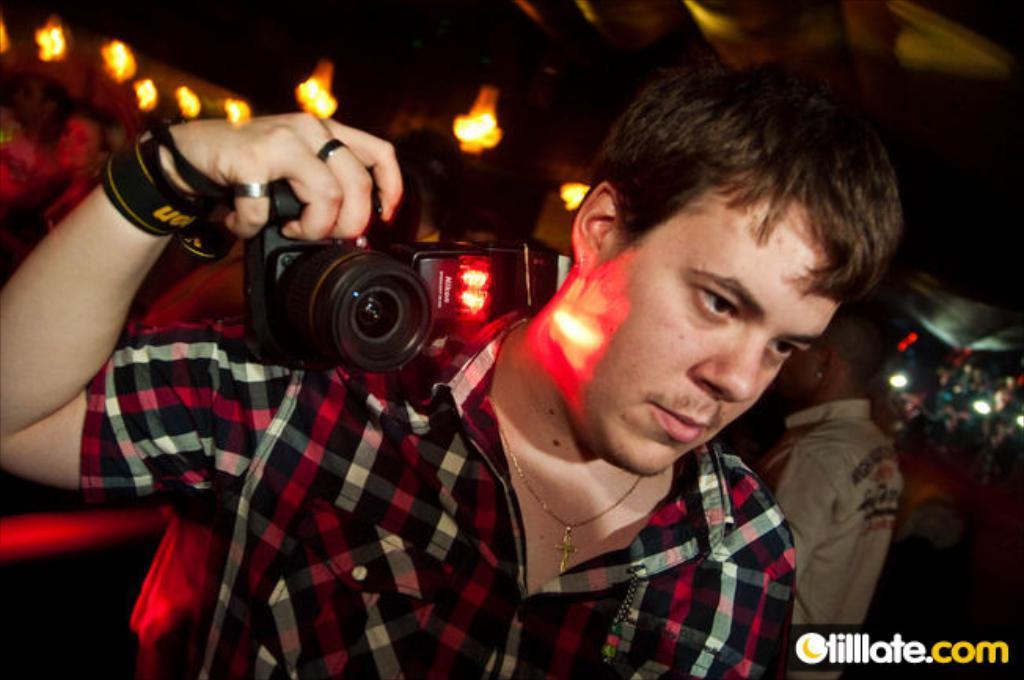How would you summarize this image in a sentence or two? In the image we can see there is a man who is standing and holding camera in his hand. 